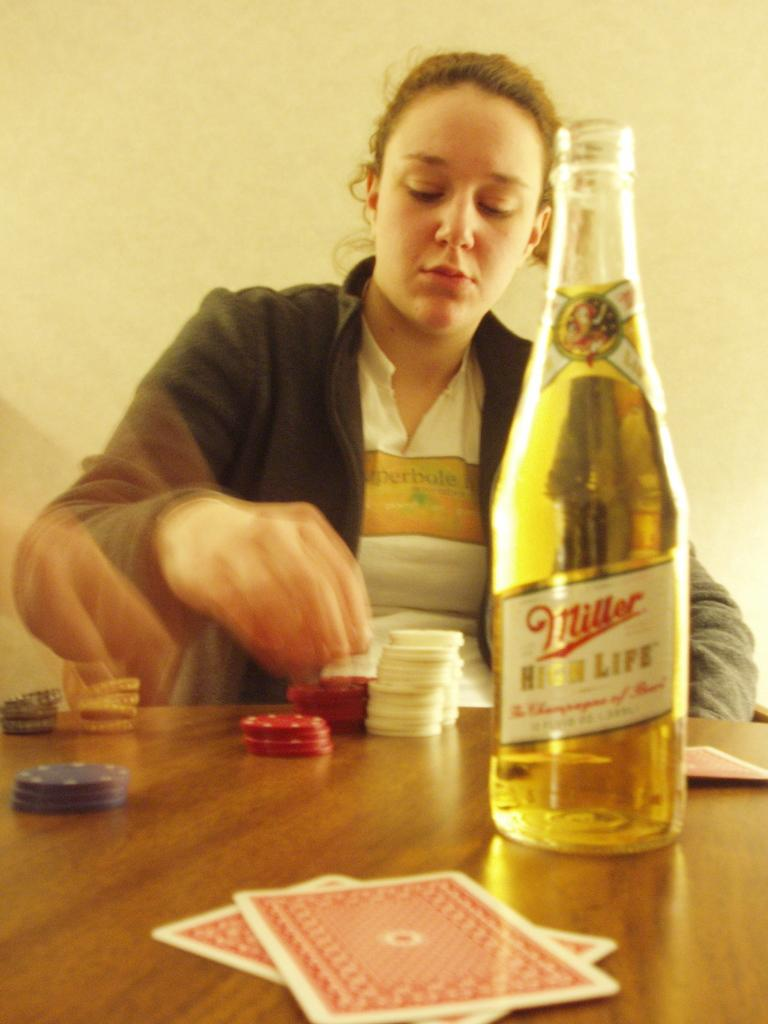What is on the table in the image? There is a wine bottle on the table. What is happening in the background of the image? There is a woman in the background of the image, and she is playing with casino coins and playing cards. What type of snake can be seen slithering on the table in the image? There is no snake present in the image; the only items on the table are the wine bottle and the items mentioned in the background. 